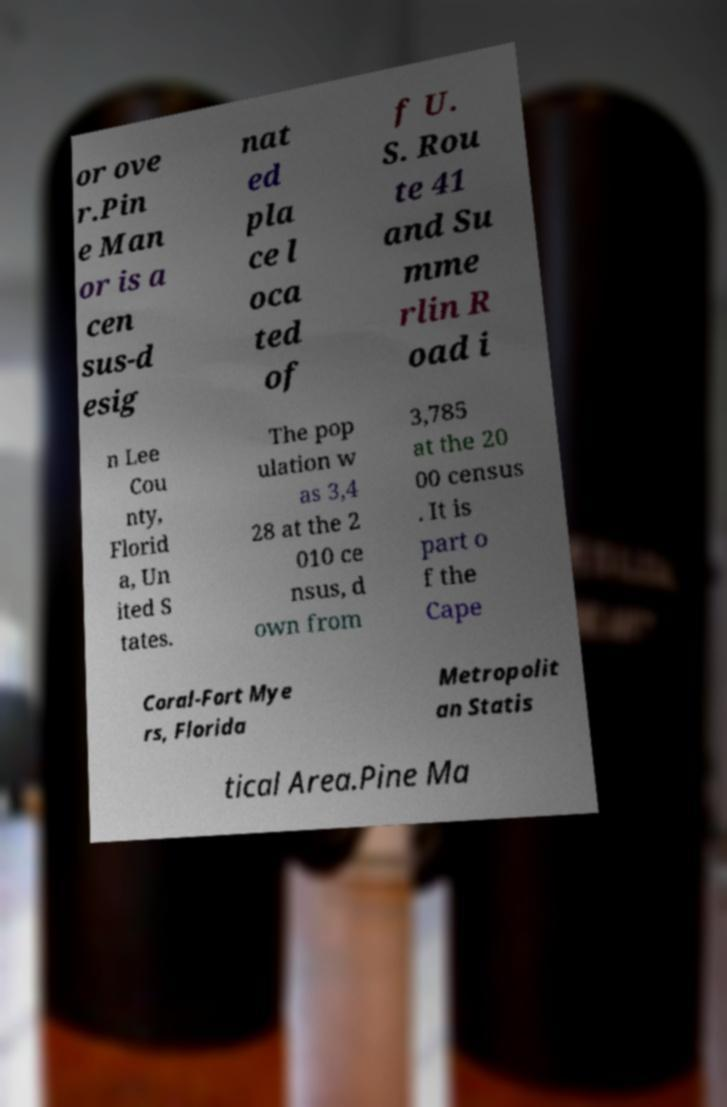I need the written content from this picture converted into text. Can you do that? or ove r.Pin e Man or is a cen sus-d esig nat ed pla ce l oca ted of f U. S. Rou te 41 and Su mme rlin R oad i n Lee Cou nty, Florid a, Un ited S tates. The pop ulation w as 3,4 28 at the 2 010 ce nsus, d own from 3,785 at the 20 00 census . It is part o f the Cape Coral-Fort Mye rs, Florida Metropolit an Statis tical Area.Pine Ma 